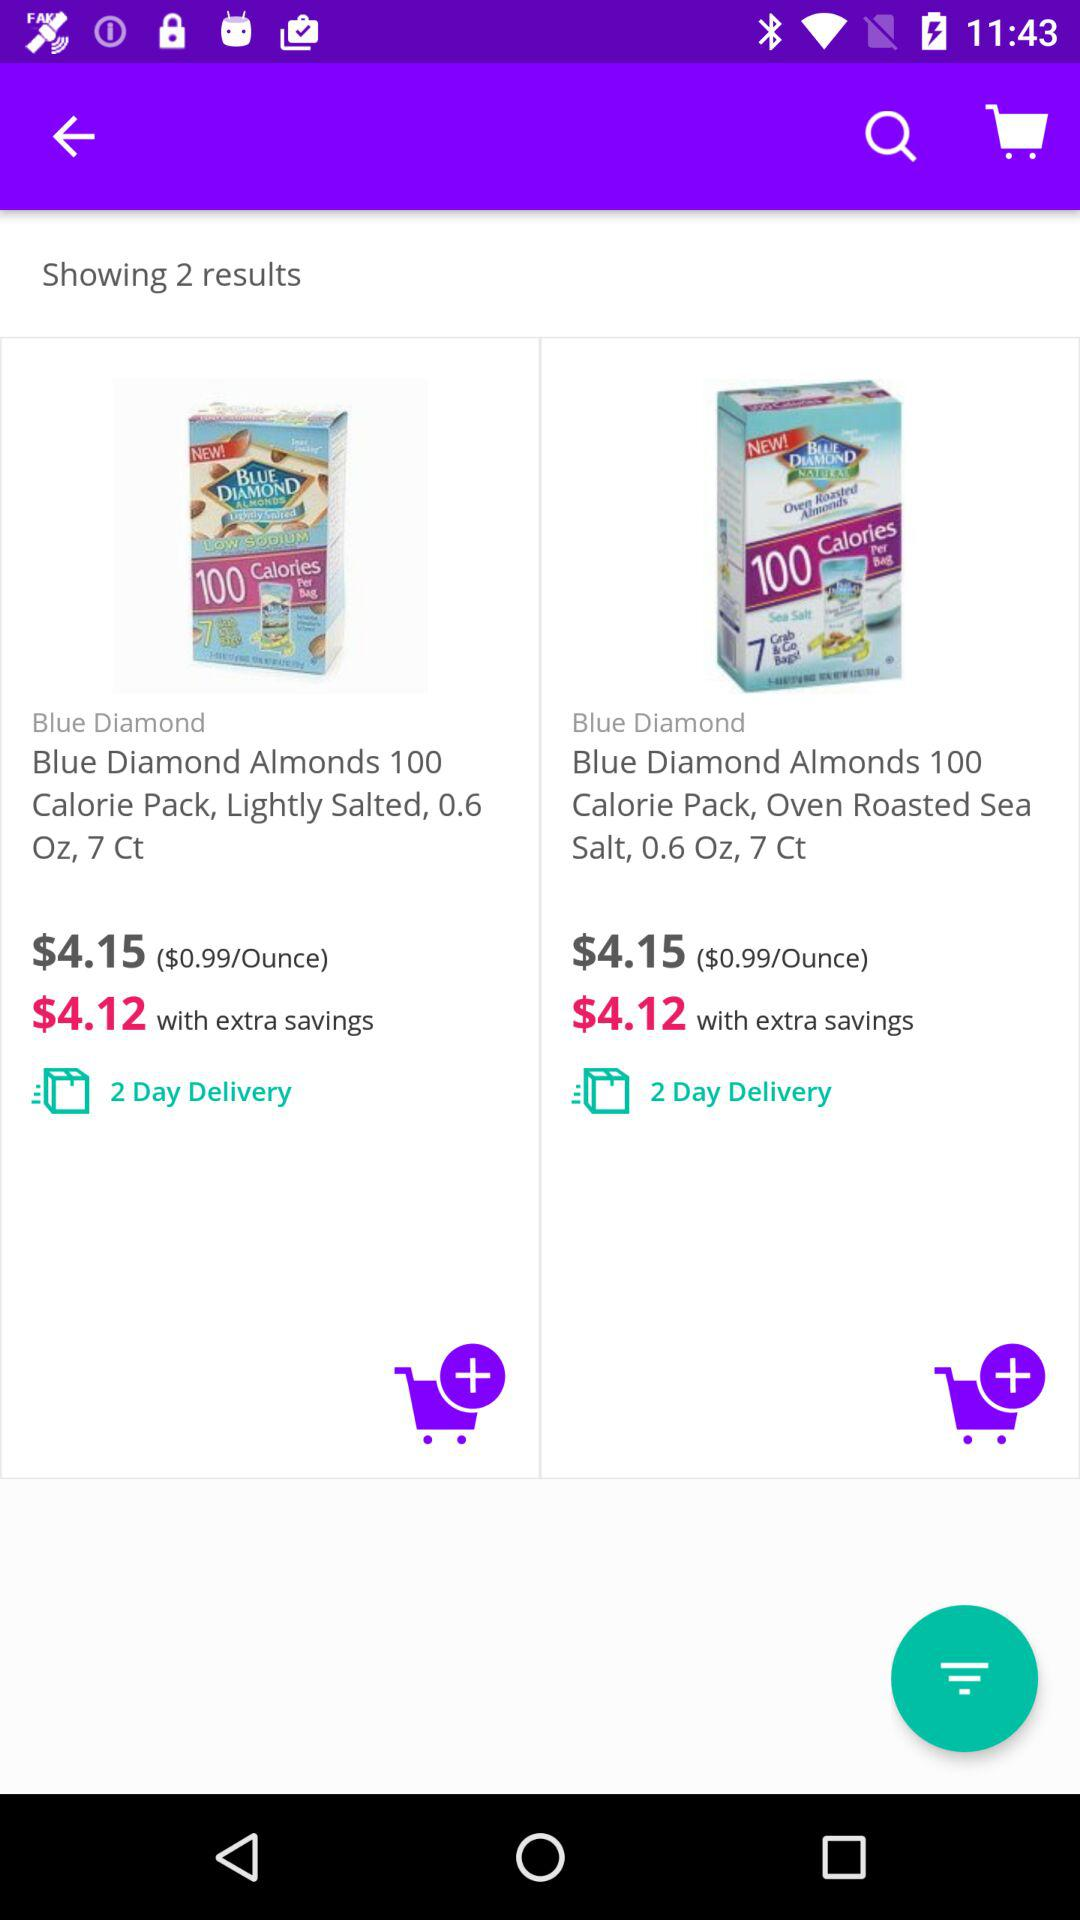What options do I have for delivery if I order one of these products? Both products in the search results are eligible for 2-day delivery, which is a convenient option if you need the items quickly. This information is clearly indicated under each item with a green truck icon and the label '2 Day Delivery.' 